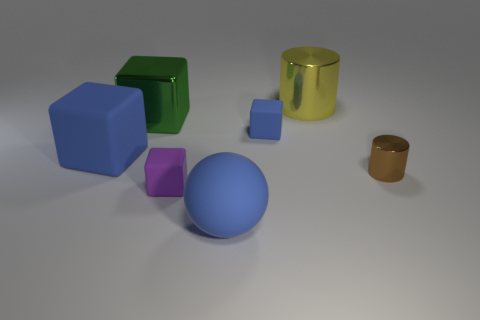Subtract all small blue cubes. How many cubes are left? 3 Add 2 large blue objects. How many objects exist? 9 Subtract all red cubes. Subtract all red balls. How many cubes are left? 4 Subtract all balls. How many objects are left? 6 Add 3 purple rubber cubes. How many purple rubber cubes are left? 4 Add 2 big yellow cylinders. How many big yellow cylinders exist? 3 Subtract 0 green cylinders. How many objects are left? 7 Subtract all large blue matte blocks. Subtract all big green objects. How many objects are left? 5 